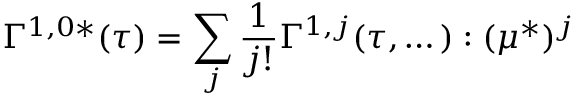<formula> <loc_0><loc_0><loc_500><loc_500>\Gamma ^ { 1 , 0 * } ( \tau ) = \sum _ { j } \frac { 1 } { j ! } \Gamma ^ { 1 , j } ( \tau , \dots ) \colon ( \mu ^ { * } ) ^ { j }</formula> 